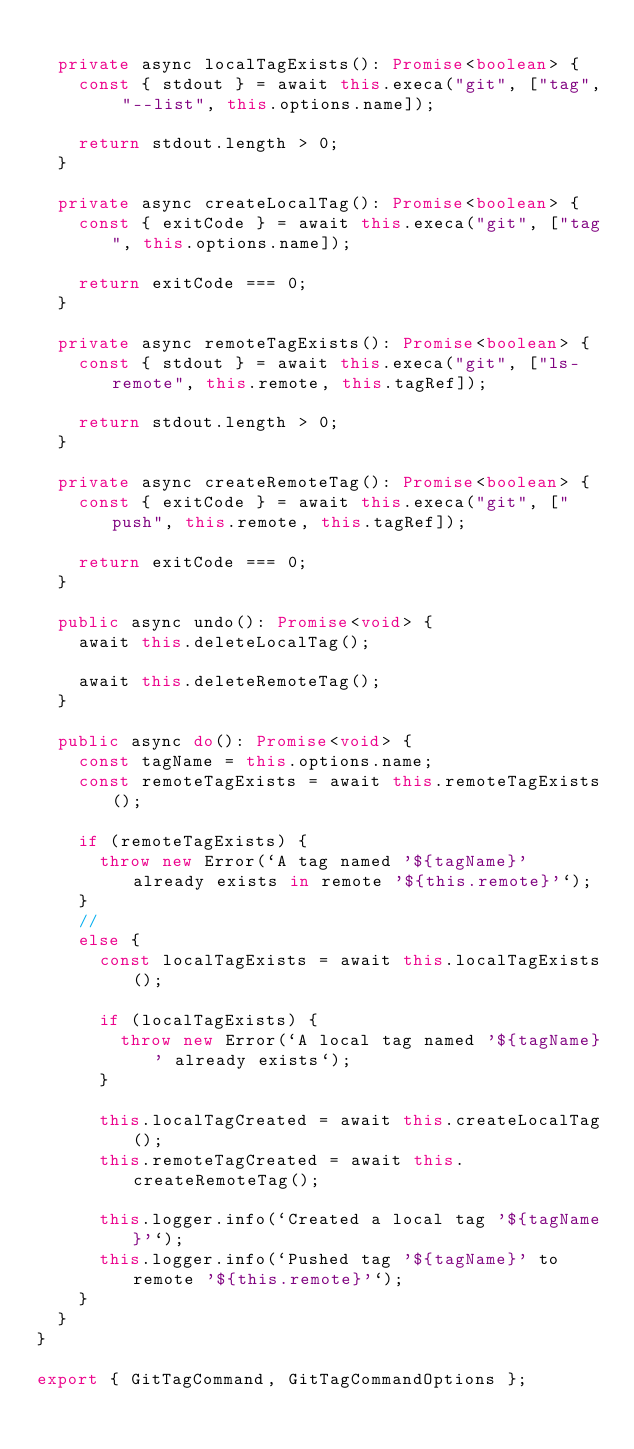<code> <loc_0><loc_0><loc_500><loc_500><_TypeScript_>
  private async localTagExists(): Promise<boolean> {
    const { stdout } = await this.execa("git", ["tag", "--list", this.options.name]);

    return stdout.length > 0;
  }

  private async createLocalTag(): Promise<boolean> {
    const { exitCode } = await this.execa("git", ["tag", this.options.name]);

    return exitCode === 0;
  }

  private async remoteTagExists(): Promise<boolean> {
    const { stdout } = await this.execa("git", ["ls-remote", this.remote, this.tagRef]);

    return stdout.length > 0;
  }

  private async createRemoteTag(): Promise<boolean> {
    const { exitCode } = await this.execa("git", ["push", this.remote, this.tagRef]);

    return exitCode === 0;
  }

  public async undo(): Promise<void> {
    await this.deleteLocalTag();

    await this.deleteRemoteTag();
  }

  public async do(): Promise<void> {
    const tagName = this.options.name;
    const remoteTagExists = await this.remoteTagExists();

    if (remoteTagExists) {
      throw new Error(`A tag named '${tagName}' already exists in remote '${this.remote}'`);
    }
    //
    else {
      const localTagExists = await this.localTagExists();

      if (localTagExists) {
        throw new Error(`A local tag named '${tagName}' already exists`);
      }

      this.localTagCreated = await this.createLocalTag();
      this.remoteTagCreated = await this.createRemoteTag();

      this.logger.info(`Created a local tag '${tagName}'`);
      this.logger.info(`Pushed tag '${tagName}' to remote '${this.remote}'`);
    }
  }
}

export { GitTagCommand, GitTagCommandOptions };
</code> 